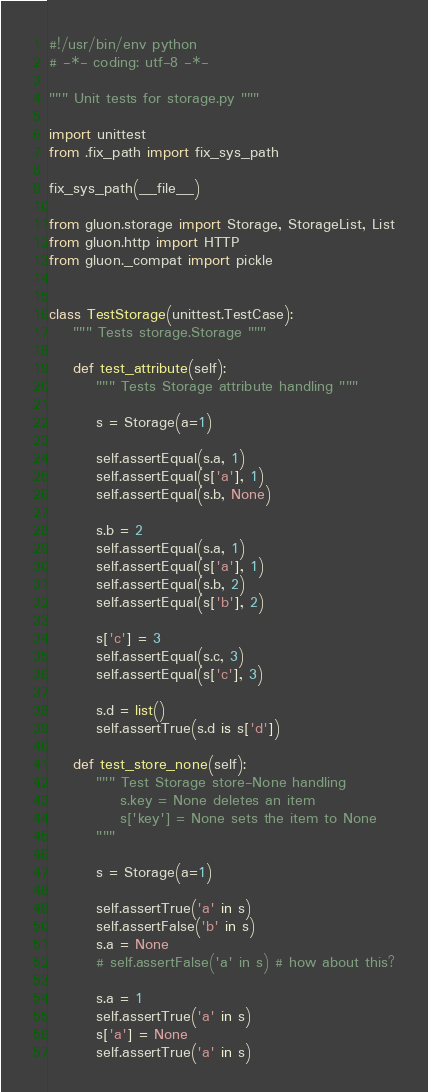Convert code to text. <code><loc_0><loc_0><loc_500><loc_500><_Python_>#!/usr/bin/env python
# -*- coding: utf-8 -*-

""" Unit tests for storage.py """

import unittest
from .fix_path import fix_sys_path

fix_sys_path(__file__)

from gluon.storage import Storage, StorageList, List
from gluon.http import HTTP
from gluon._compat import pickle


class TestStorage(unittest.TestCase):
    """ Tests storage.Storage """

    def test_attribute(self):
        """ Tests Storage attribute handling """

        s = Storage(a=1)

        self.assertEqual(s.a, 1)
        self.assertEqual(s['a'], 1)
        self.assertEqual(s.b, None)

        s.b = 2
        self.assertEqual(s.a, 1)
        self.assertEqual(s['a'], 1)
        self.assertEqual(s.b, 2)
        self.assertEqual(s['b'], 2)

        s['c'] = 3
        self.assertEqual(s.c, 3)
        self.assertEqual(s['c'], 3)

        s.d = list()
        self.assertTrue(s.d is s['d'])

    def test_store_none(self):
        """ Test Storage store-None handling
            s.key = None deletes an item
            s['key'] = None sets the item to None
        """

        s = Storage(a=1)

        self.assertTrue('a' in s)
        self.assertFalse('b' in s)
        s.a = None
        # self.assertFalse('a' in s) # how about this?

        s.a = 1
        self.assertTrue('a' in s)
        s['a'] = None
        self.assertTrue('a' in s)</code> 